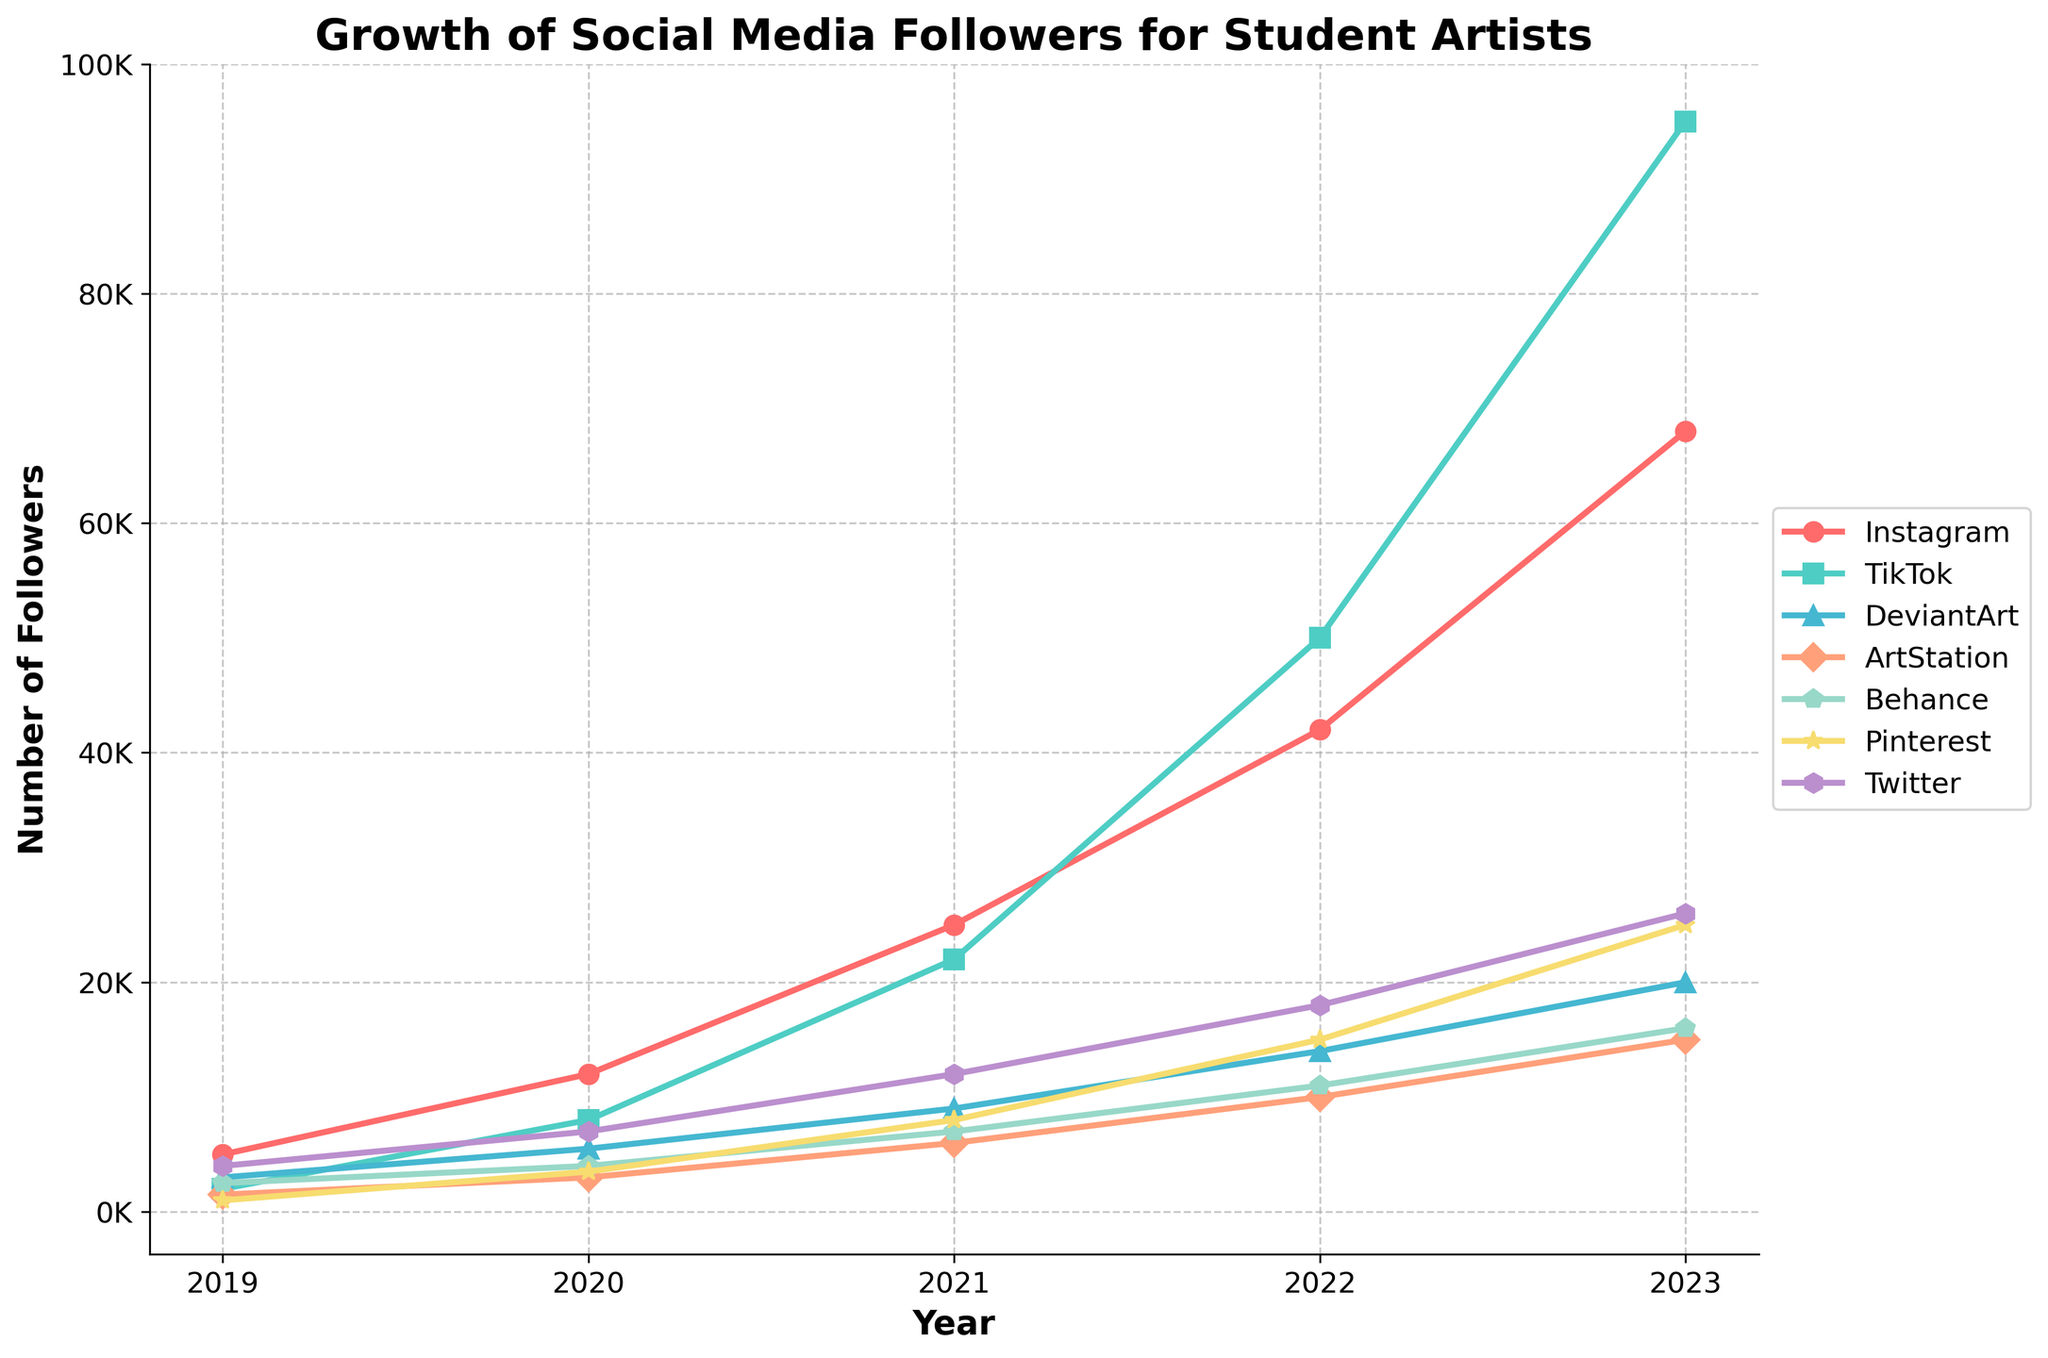What platform had the highest number of followers in 2023? Look at the endpoints of each line in the graph for the year 2023 and identify the platform associated with the highest point. TikTok has the highest number of followers in 2023.
Answer: TikTok Which platform saw the greatest increase in followers from 2019 to 2023? Calculate the difference in followers between 2019 and 2023 for each platform. TikTok increased from 2000 to 95000, which is an increase of 93000, the highest among all platforms.
Answer: TikTok How did Instagram's growth compare to Pinterest's growth from 2019 to 2023? Calculate the difference for each platform over the given period: Instagram (68000 - 5000 = 63000) and Pinterest (25000 - 1000 = 24000). Instagram's growth was greater.
Answer: Instagram’s growth was greater What was the total number of followers for all platforms in 2021? Sum the number of followers for all platforms for the year 2021: 25000 + 22000 + 9000 + 6000 + 7000 + 8000 + 12000. The total is 89000.
Answer: 89000 Which platform had the smallest number of followers in 2020? Look at the data points for each platform in the year 2020 and identify the smallest value, which is for ArtStation (3000).
Answer: ArtStation By how much did DeviantArt's followers grow from 2019 to 2023? Calculate the difference in followers between 2023 and 2019 for DeviantArt: 20000 - 3000 = 17000.
Answer: 17000 Which platform had the most consistent follower growth over the years? Examine the lines' slopes for each platform and identify the one with the smallest variation in slope. Behance shows a consistently steady increase with roughly equal increments each year.
Answer: Behance What platform had the second-highest number of followers in 2023? Find the platform with the second-highest point on the graph for 2023, which is Instagram with 68000 followers.
Answer: Instagram How many platforms had fewer than 10,000 followers in 2020? Count the platforms with followers below 10,000 in the year 2020. DeviantArt, ArtStation, and Pinterest, all three had fewer followers.
Answer: 3 Did any platform other than TikTok exceed 50,000 followers by 2023? Check the 2023 data points for platforms other than TikTok. No other platform exceeds 50,000 followers by 2023.
Answer: No 